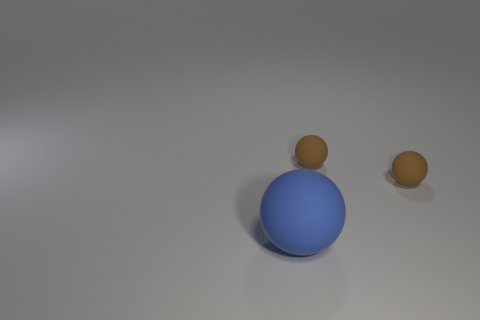Subtract all tiny brown rubber balls. How many balls are left? 1 Subtract all blue balls. How many balls are left? 2 Add 3 big blue things. How many objects exist? 6 Subtract all purple spheres. Subtract all gray cylinders. How many spheres are left? 3 Subtract all brown cylinders. How many brown balls are left? 2 Subtract all small brown rubber balls. Subtract all blue balls. How many objects are left? 0 Add 2 rubber balls. How many rubber balls are left? 5 Add 2 large blue balls. How many large blue balls exist? 3 Subtract 0 cyan cubes. How many objects are left? 3 